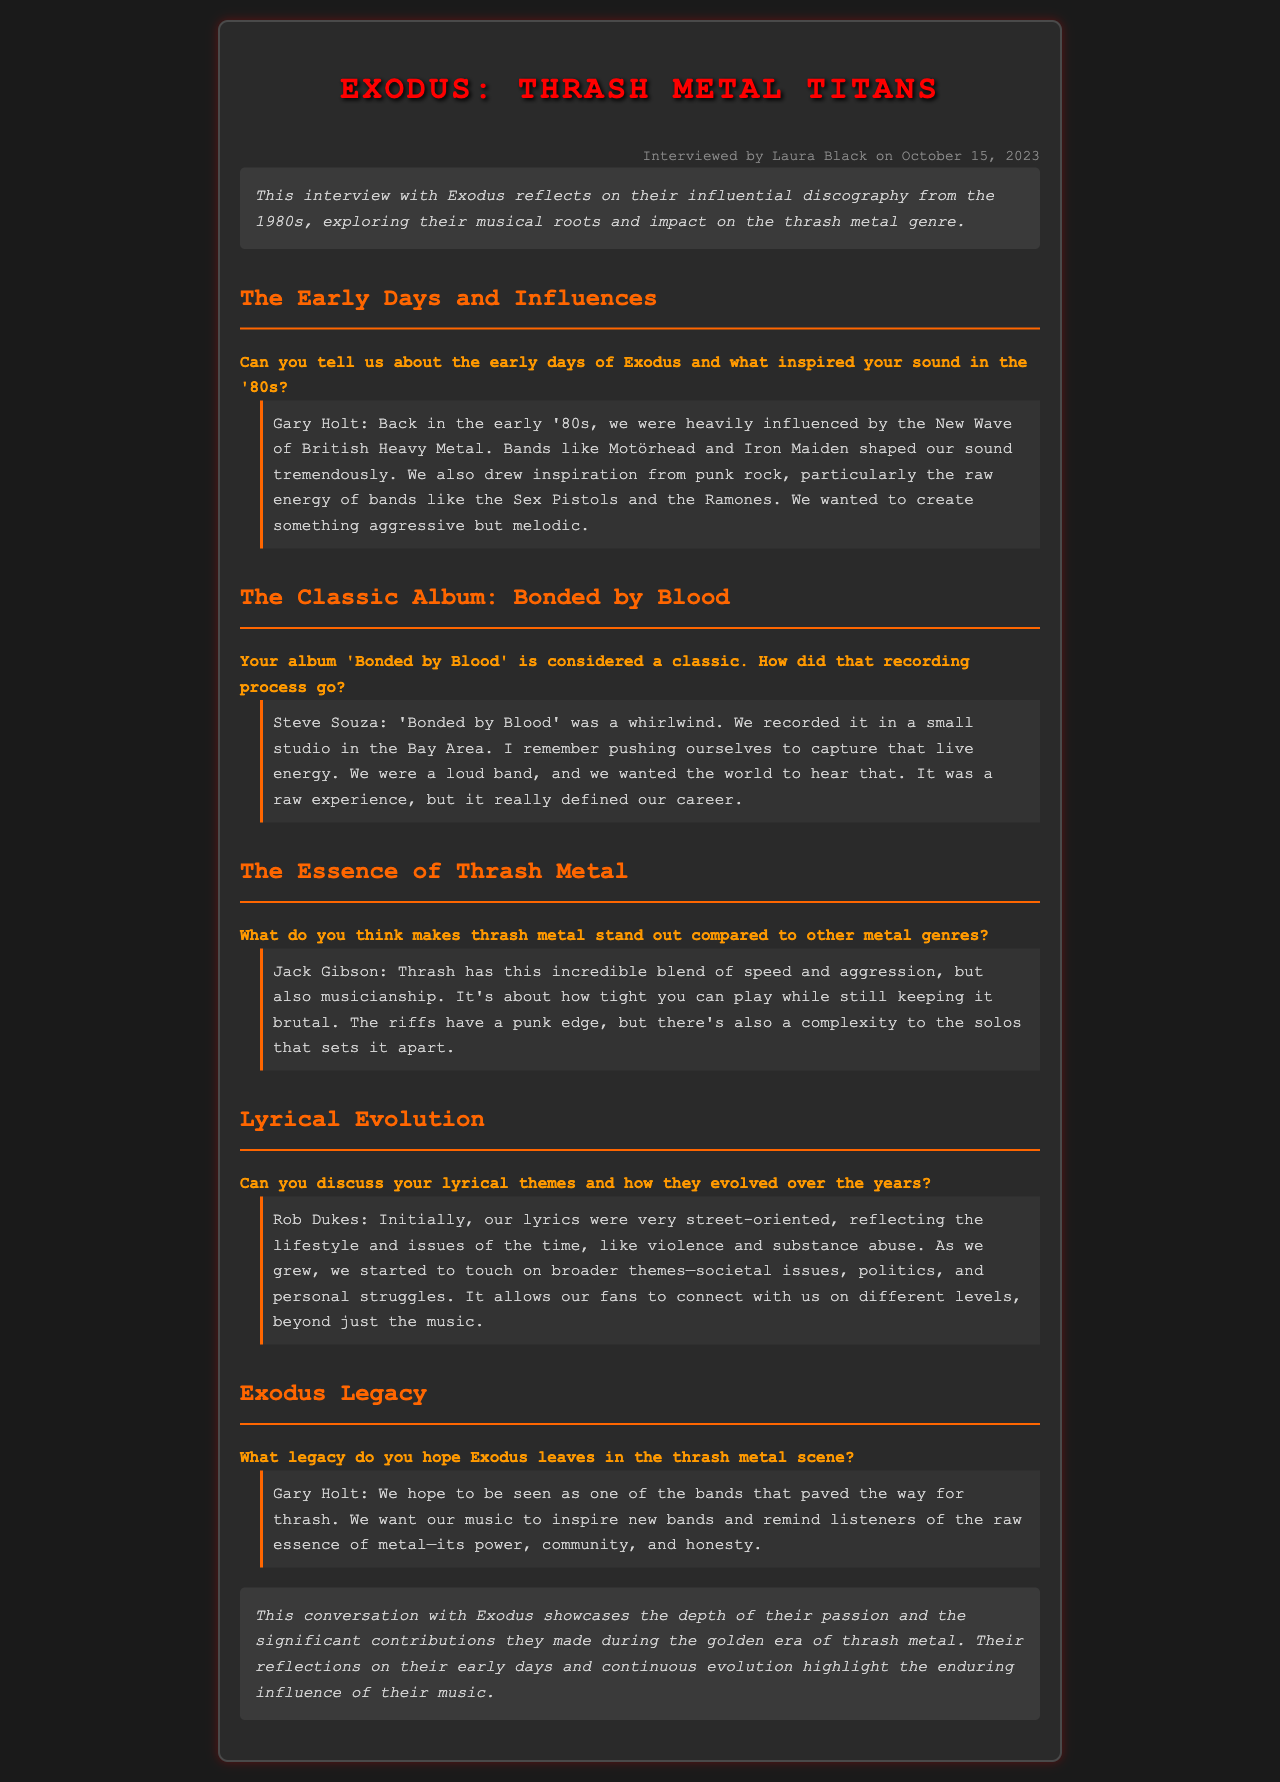What is the title of the interview? The title of the interview is prominently displayed at the top of the document.
Answer: Exodus: Thrash Metal Titans Who interviewed Exodus? The name of the interviewer is mentioned in the metadata section of the document.
Answer: Laura Black When was the interview conducted? The date of the interview is provided in the metadata section.
Answer: October 15, 2023 What is the name of the classic album discussed in the interview? The title of the classic album is specifically mentioned in the question about the recording process.
Answer: Bonded by Blood What musical influences shaped Exodus's sound in the '80s? The influences are listed by a band member in their response related to early days.
Answer: Motörhead, Iron Maiden, punk rock Who believes that thrash metal combines speed, aggression, and musicianship? The specific member who discusses the essence of thrash metal is cited in their response.
Answer: Jack Gibson What were the initial lyrical themes of Exodus? The initial themes of their lyrics are described in Rob Dukes's response about lyrical evolution.
Answer: Street-oriented, violence, substance abuse What legacy does Exodus hope to leave in the thrash metal scene? The band's hopes for their legacy are articulated in Gary Holt's response.
Answer: Paved the way for thrash What type of musical energy did Exodus aim to capture in 'Bonded by Blood'? The kind of energy they wanted to capture is mentioned in the recording process response.
Answer: Live energy 